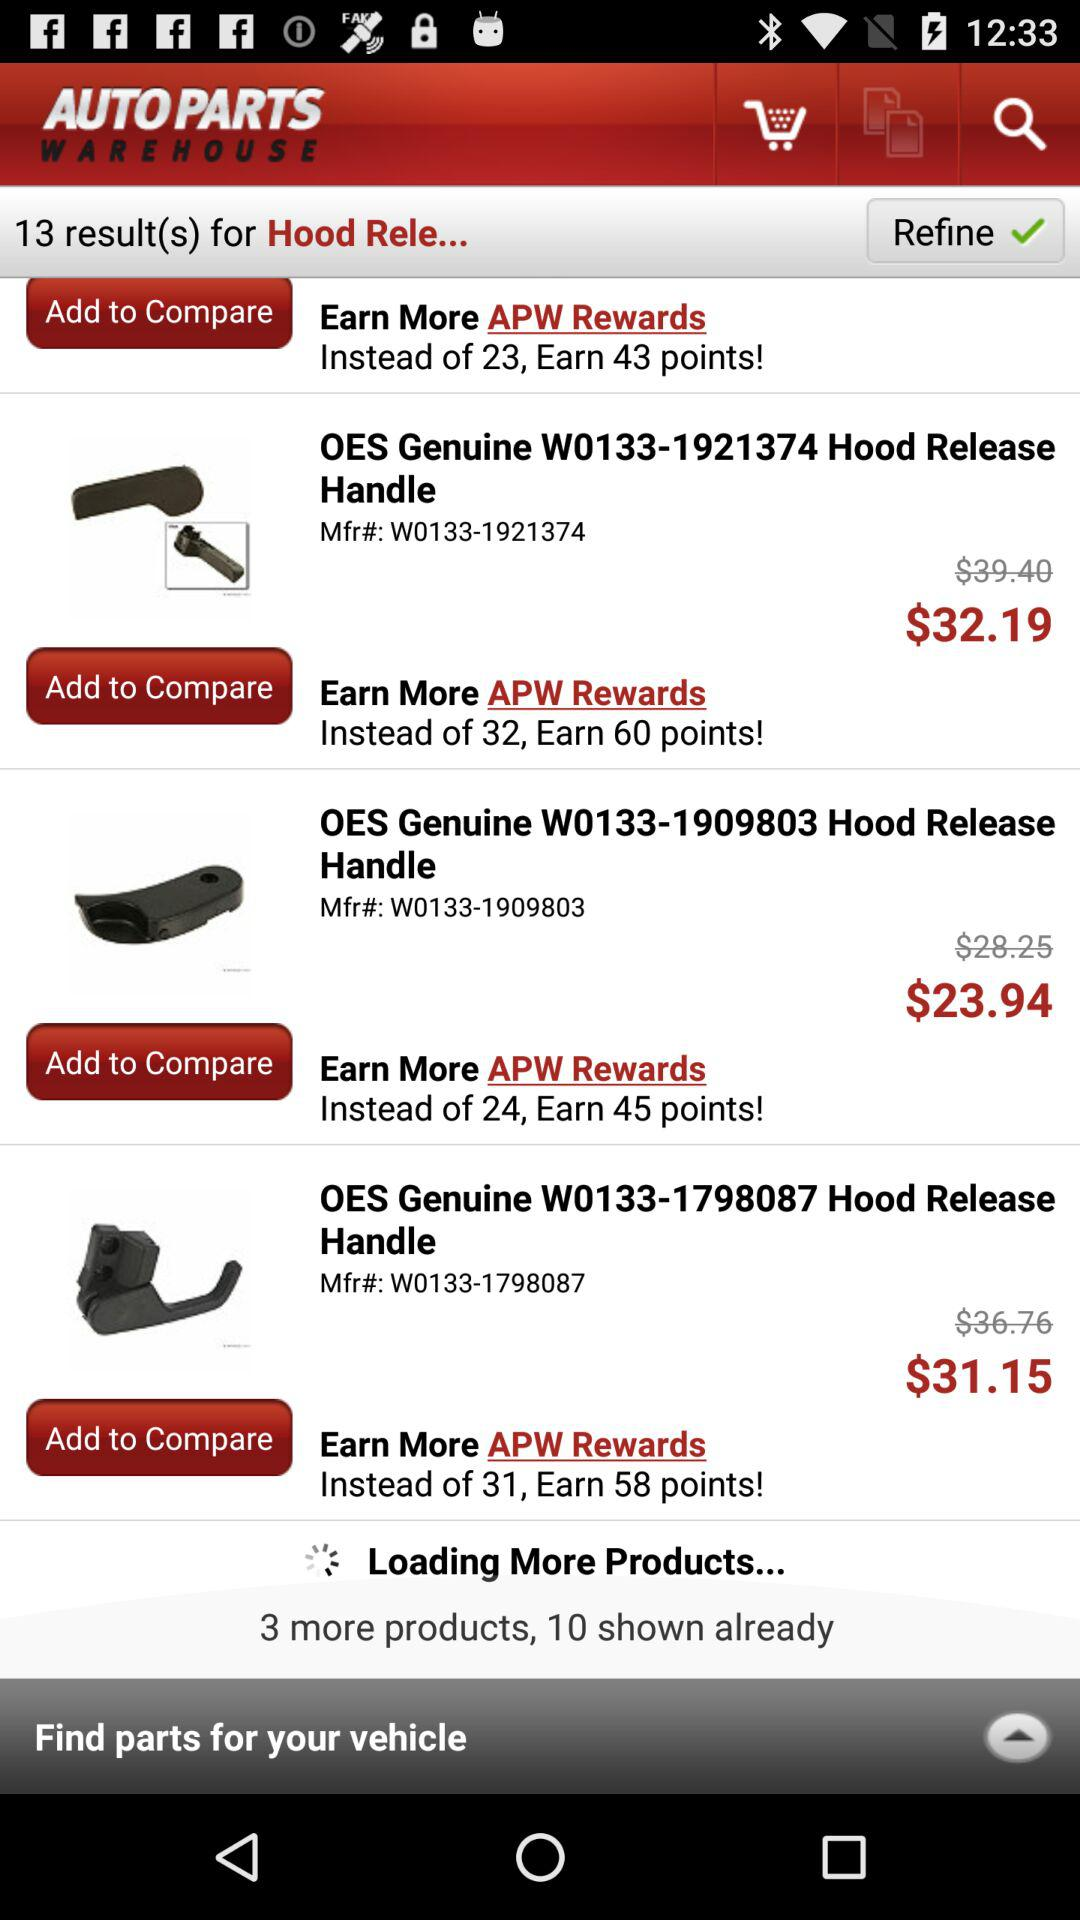How many points can we earn by purchasing "OES Genuine W0133-1909803"? You can earn 45 points by purchasing "OES Genuine W0133-1909803". 